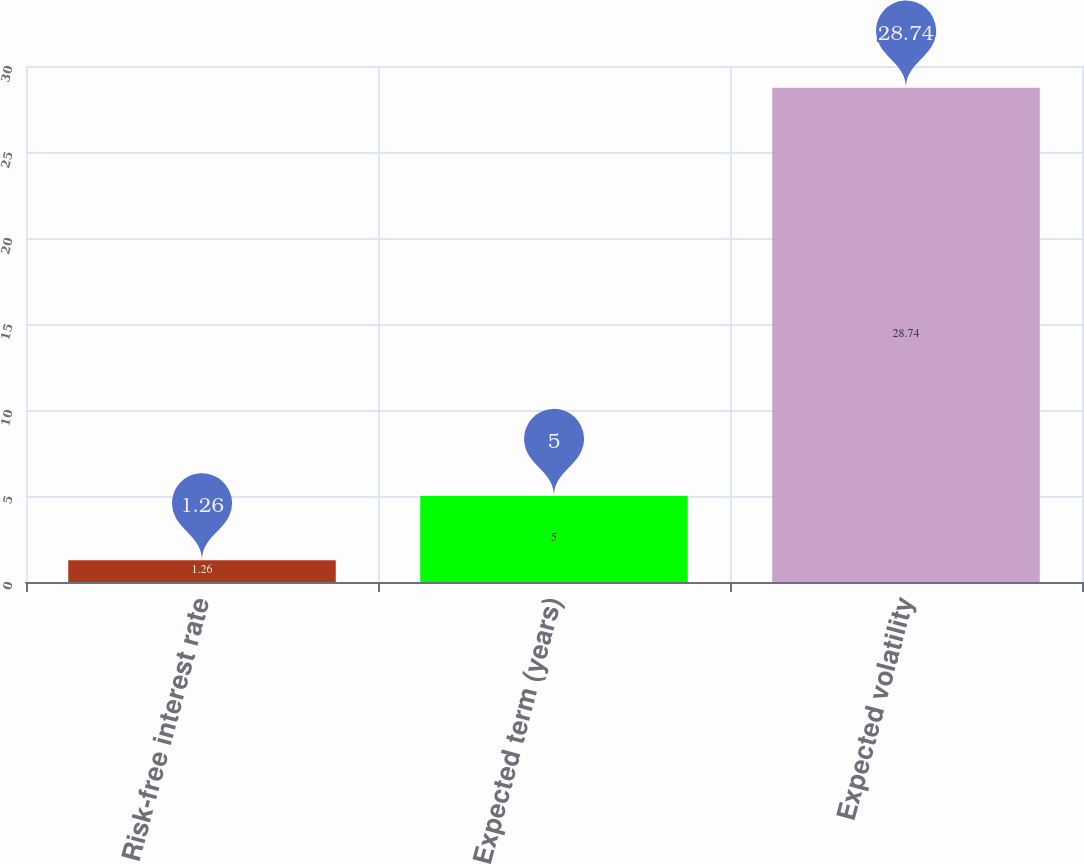Convert chart. <chart><loc_0><loc_0><loc_500><loc_500><bar_chart><fcel>Risk-free interest rate<fcel>Expected term (years)<fcel>Expected volatility<nl><fcel>1.26<fcel>5<fcel>28.74<nl></chart> 